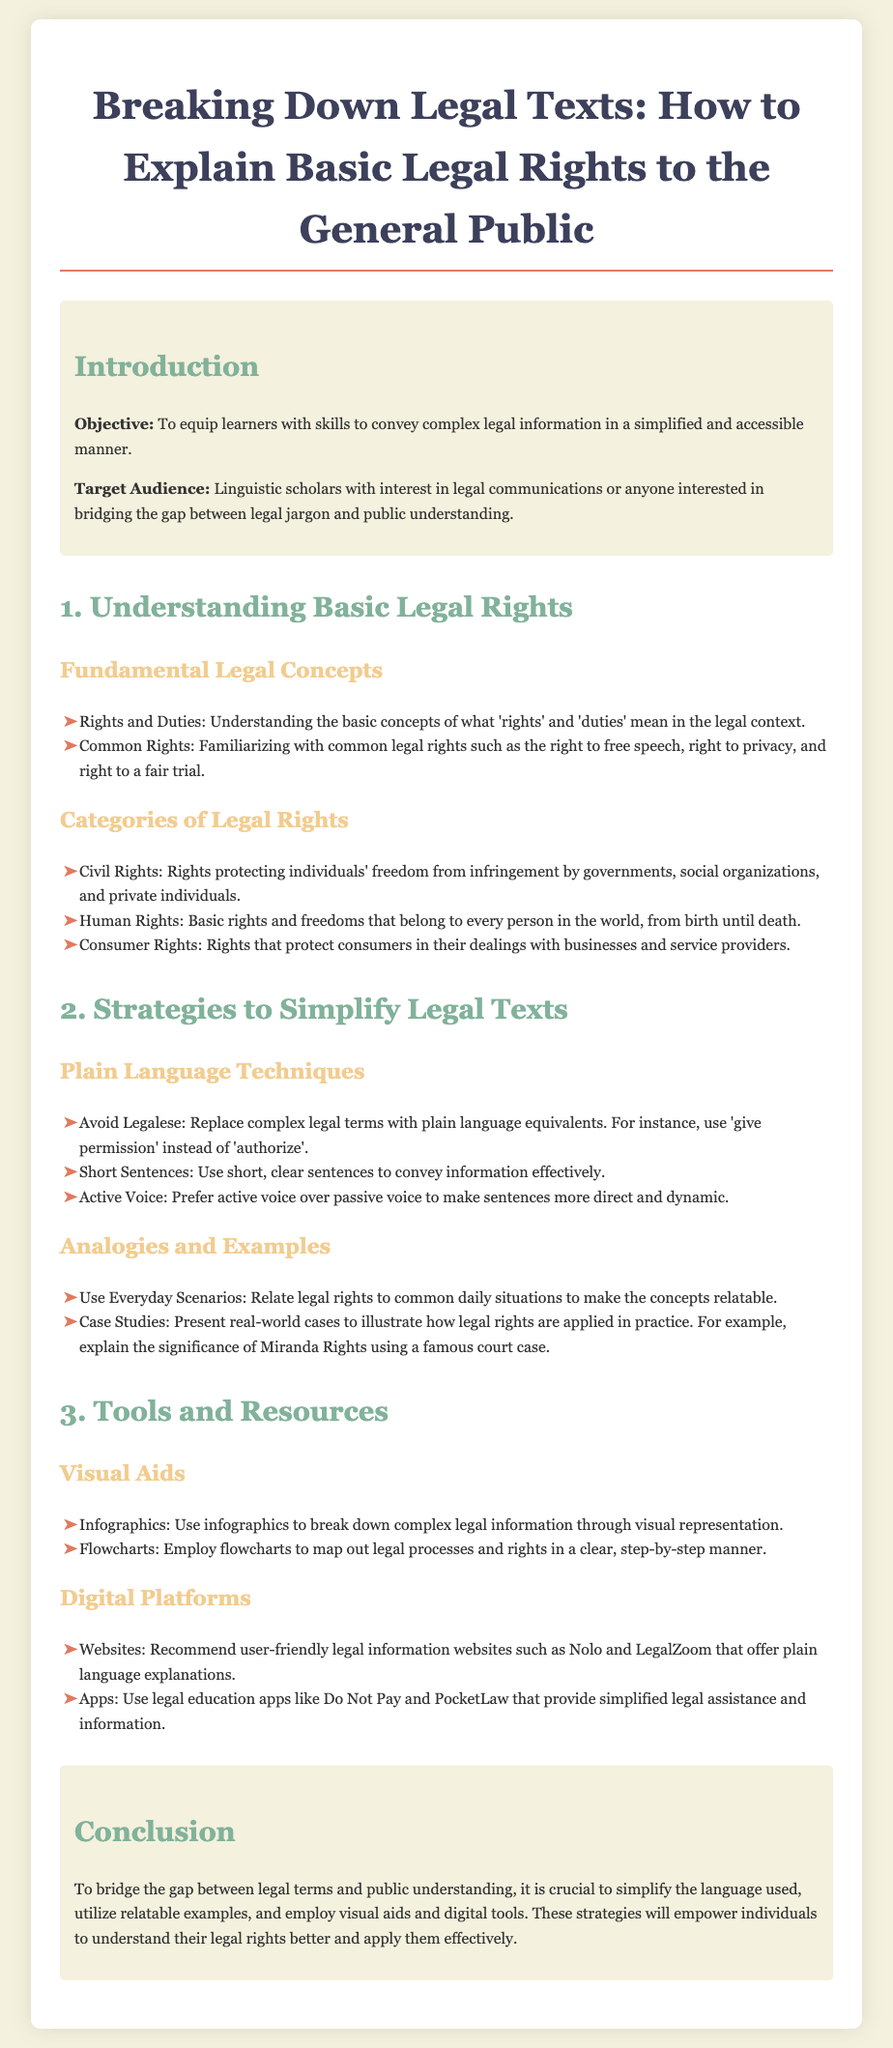What is the objective of the lesson? The objective is to equip learners with skills to convey complex legal information in a simplified and accessible manner.
Answer: To equip learners with skills to convey complex legal information in a simplified and accessible manner Who is the target audience? The target audience is mentioned as linguistic scholars with interest in legal communications or anyone interested in bridging the gap between legal jargon and public understanding.
Answer: Linguistic scholars with interest in legal communications or anyone interested in bridging the gap between legal jargon and public understanding What are common legal rights listed in the document? The document specifies common legal rights such as the right to free speech, right to privacy, and right to a fair trial.
Answer: Right to free speech, right to privacy, right to a fair trial Name one plain language technique suggested. The document recommends avoiding legalese, which means replacing complex legal terms with plain language equivalents.
Answer: Avoid Legalese How many categories of legal rights are mentioned? The document lists three categories of legal rights: civil rights, human rights, and consumer rights.
Answer: Three What visual aid is suggested for breaking down legal information? The document suggests using infographics as a visual aid for presenting complex legal information.
Answer: Infographics Which digital platform is recommended for legal information? The document recommends user-friendly legal information websites such as Nolo and LegalZoom.
Answer: Nolo and LegalZoom What is the main theme of the conclusion? The conclusion emphasizes the importance of simplifying language, using examples, and employing visual aids to enhance public understanding of legal rights.
Answer: Simplifying language and using examples What teaching strategy involves everyday scenarios? The document indicates using analogies and examples to relate legal rights to common daily situations.
Answer: Analogies and examples 